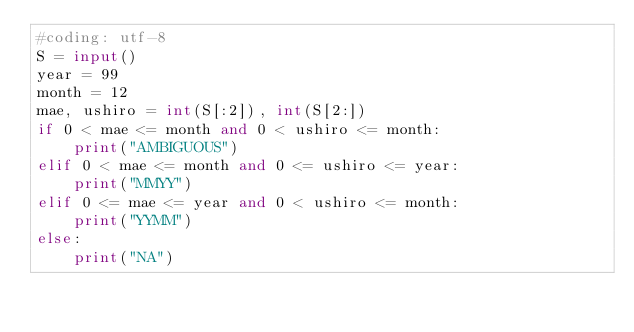<code> <loc_0><loc_0><loc_500><loc_500><_Python_>#coding: utf-8
S = input()
year = 99
month = 12
mae, ushiro = int(S[:2]), int(S[2:])
if 0 < mae <= month and 0 < ushiro <= month:
	print("AMBIGUOUS")
elif 0 < mae <= month and 0 <= ushiro <= year:
	print("MMYY")
elif 0 <= mae <= year and 0 < ushiro <= month:
	print("YYMM")
else:
	print("NA")
</code> 